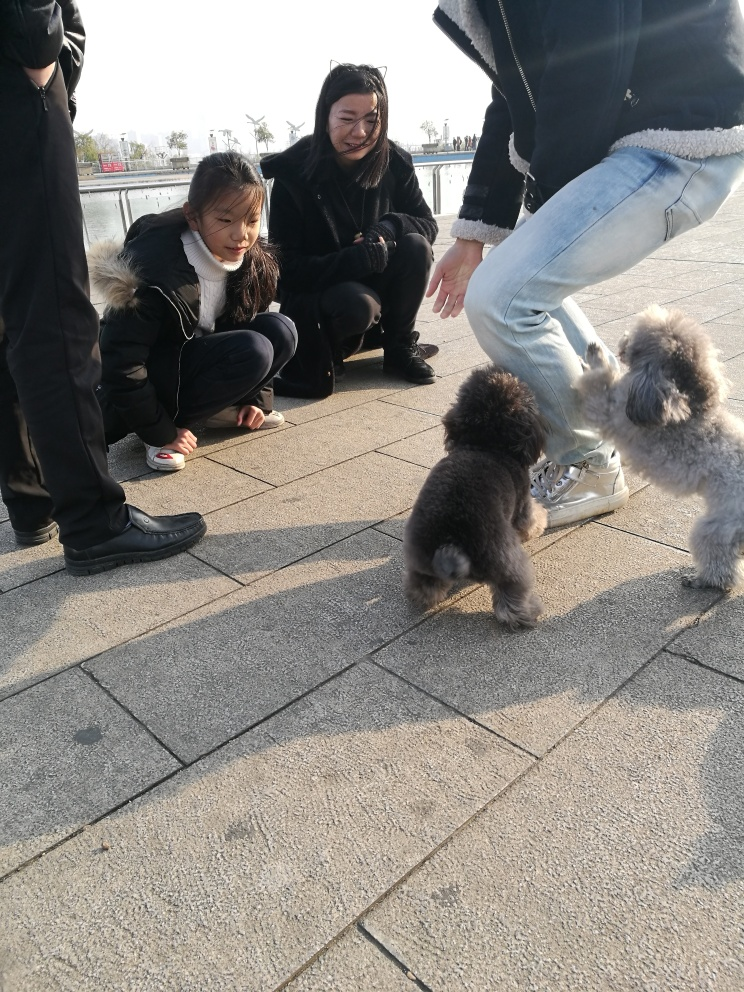Are the colors in the image dull? The image showcases a mix of both muted and brighter colors. The people's clothes and the pavement have subdued tones, which might give an impression of dullness. However, the dogs’ fur, which varies from light to darker shades, adds some contrast to the scene. The overall lighting, which appears to be natural and soft, might also contribute to the perception of less vibrant colors. 